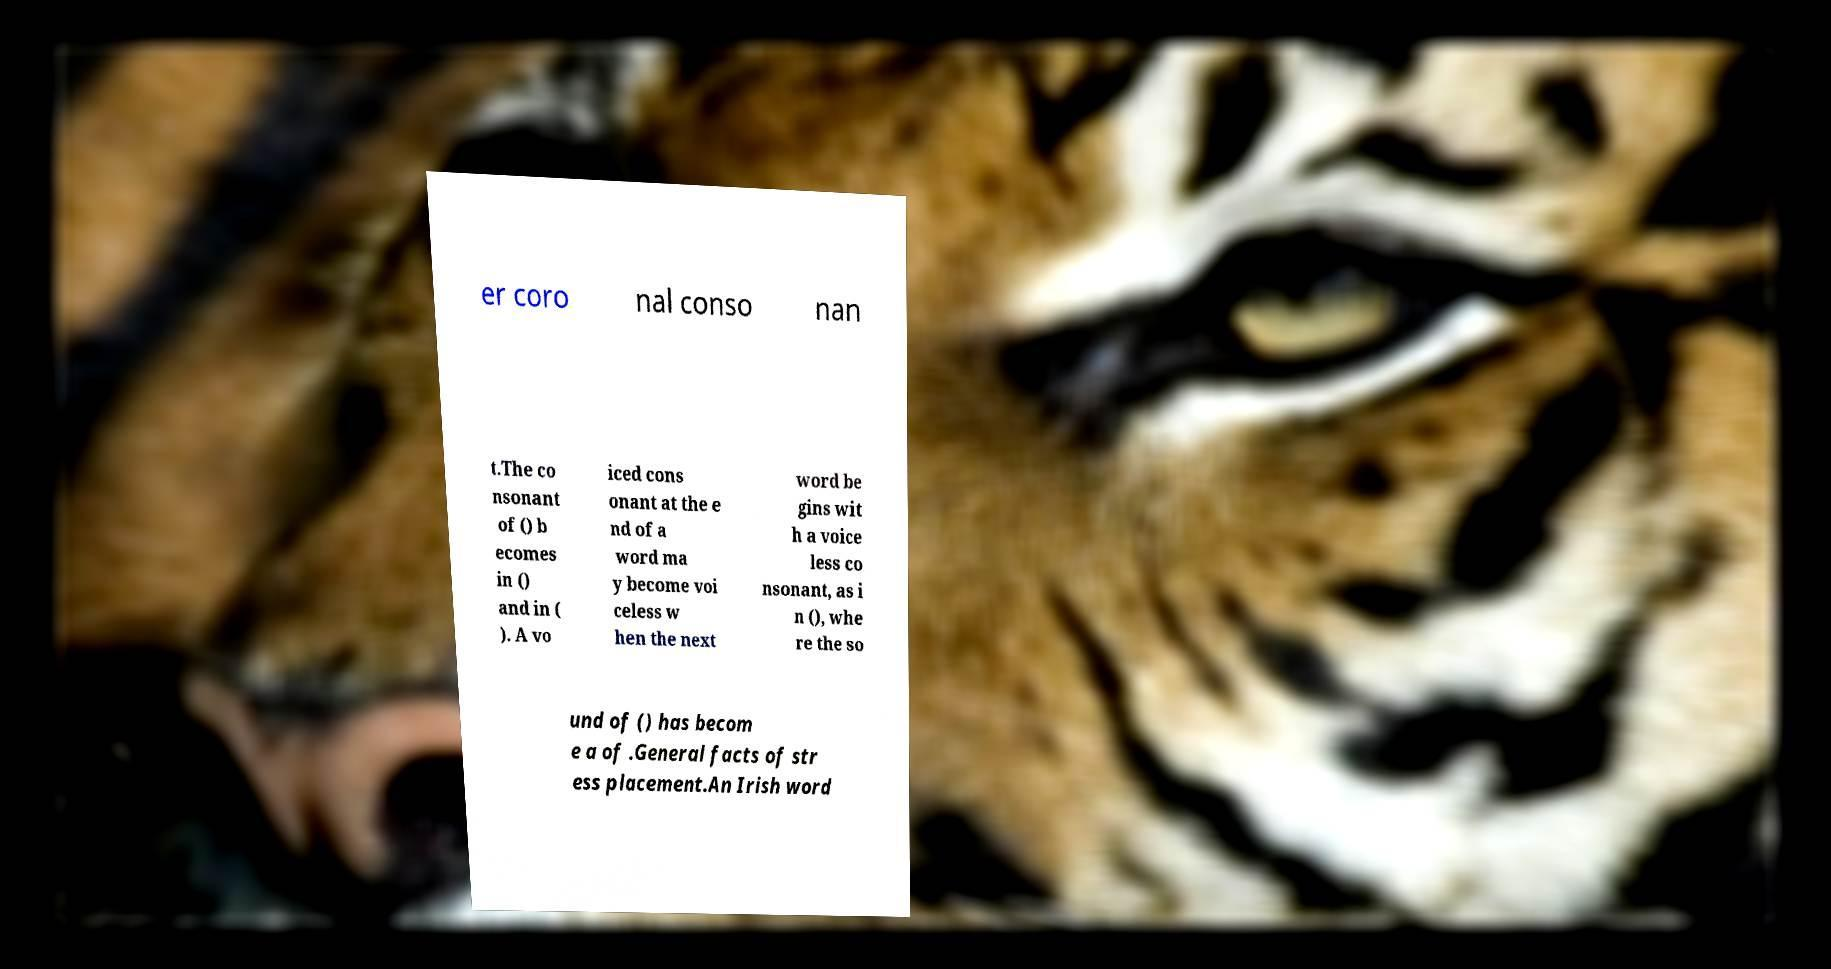I need the written content from this picture converted into text. Can you do that? er coro nal conso nan t.The co nsonant of () b ecomes in () and in ( ). A vo iced cons onant at the e nd of a word ma y become voi celess w hen the next word be gins wit h a voice less co nsonant, as i n (), whe re the so und of () has becom e a of .General facts of str ess placement.An Irish word 